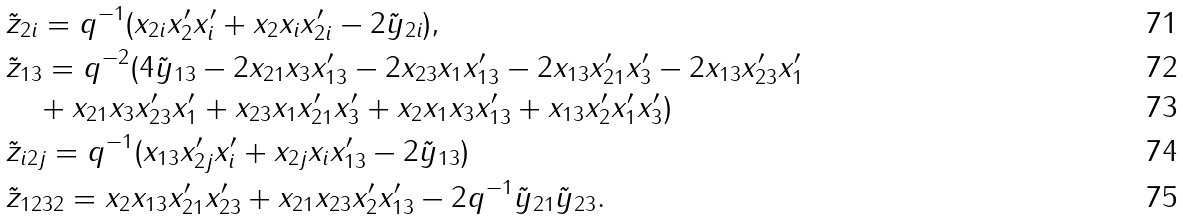Convert formula to latex. <formula><loc_0><loc_0><loc_500><loc_500>& \tilde { z } _ { 2 i } = q ^ { - 1 } ( x _ { 2 i } x _ { 2 } ^ { \prime } x _ { i } ^ { \prime } + x _ { 2 } x _ { i } x _ { 2 i } ^ { \prime } - 2 \tilde { y } _ { 2 i } ) , \\ & \tilde { z } _ { 1 3 } = q ^ { - 2 } ( 4 \tilde { y } _ { 1 3 } - 2 x _ { 2 1 } x _ { 3 } x _ { 1 3 } ^ { \prime } - 2 x _ { 2 3 } x _ { 1 } x ^ { \prime } _ { 1 3 } - 2 x _ { 1 3 } x _ { 2 1 } ^ { \prime } x _ { 3 } ^ { \prime } - 2 x _ { 1 3 } x ^ { \prime } _ { 2 3 } x ^ { \prime } _ { 1 } \\ & \quad + x _ { 2 1 } x _ { 3 } x ^ { \prime } _ { 2 3 } x ^ { \prime } _ { 1 } + x _ { 2 3 } x _ { 1 } x ^ { \prime } _ { 2 1 } x _ { 3 } ^ { \prime } + x _ { 2 } x _ { 1 } x _ { 3 } x ^ { \prime } _ { 1 3 } + x _ { 1 3 } x ^ { \prime } _ { 2 } x ^ { \prime } _ { 1 } x ^ { \prime } _ { 3 } ) \\ & \tilde { z } _ { i 2 j } = q ^ { - 1 } ( x _ { 1 3 } x ^ { \prime } _ { 2 j } x ^ { \prime } _ { i } + x _ { 2 j } x _ { i } x ^ { \prime } _ { 1 3 } - 2 \tilde { y } _ { 1 3 } ) \\ & \tilde { z } _ { 1 2 3 2 } = x _ { 2 } x _ { 1 3 } x ^ { \prime } _ { 2 1 } x ^ { \prime } _ { 2 3 } + x _ { 2 1 } x _ { 2 3 } x ^ { \prime } _ { 2 } x ^ { \prime } _ { 1 3 } - 2 q ^ { - 1 } \tilde { y } _ { 2 1 } \tilde { y } _ { 2 3 } .</formula> 